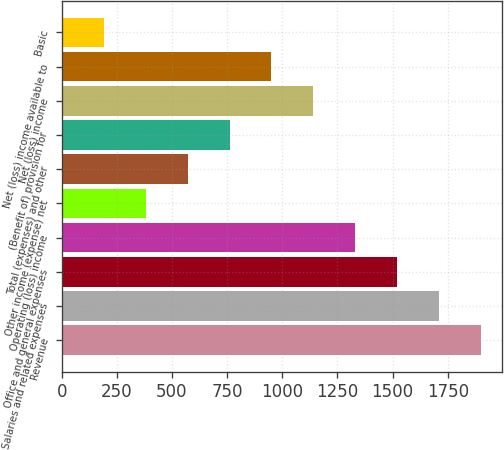Convert chart to OTSL. <chart><loc_0><loc_0><loc_500><loc_500><bar_chart><fcel>Revenue<fcel>Salaries and related expenses<fcel>Office and general expenses<fcel>Operating (loss) income<fcel>Other income (expense) net<fcel>Total (expenses) and other<fcel>(Benefit of) provision for<fcel>Net (loss) income<fcel>Net (loss) income available to<fcel>Basic<nl><fcel>1901.8<fcel>1711.65<fcel>1521.51<fcel>1331.37<fcel>380.67<fcel>570.81<fcel>760.95<fcel>1141.23<fcel>951.09<fcel>190.53<nl></chart> 